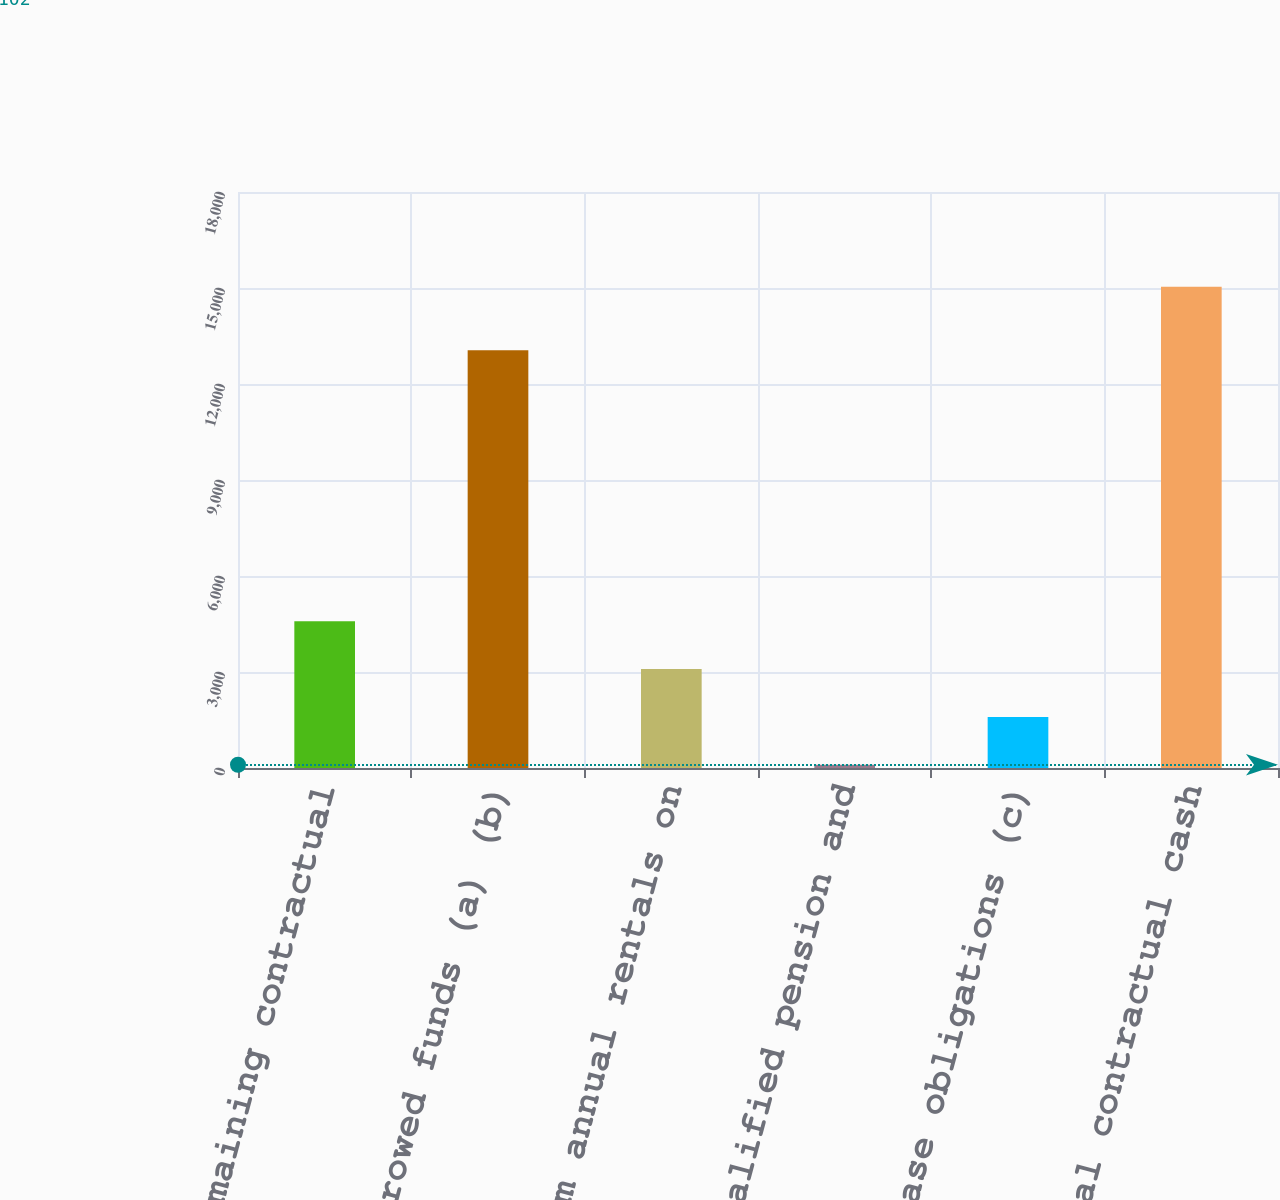<chart> <loc_0><loc_0><loc_500><loc_500><bar_chart><fcel>Remaining contractual<fcel>Borrowed funds (a) (b)<fcel>Minimum annual rentals on<fcel>Nonqualified pension and<fcel>Purchase obligations (c)<fcel>Total contractual cash<nl><fcel>4584<fcel>13052<fcel>3090<fcel>102<fcel>1596<fcel>15042<nl></chart> 